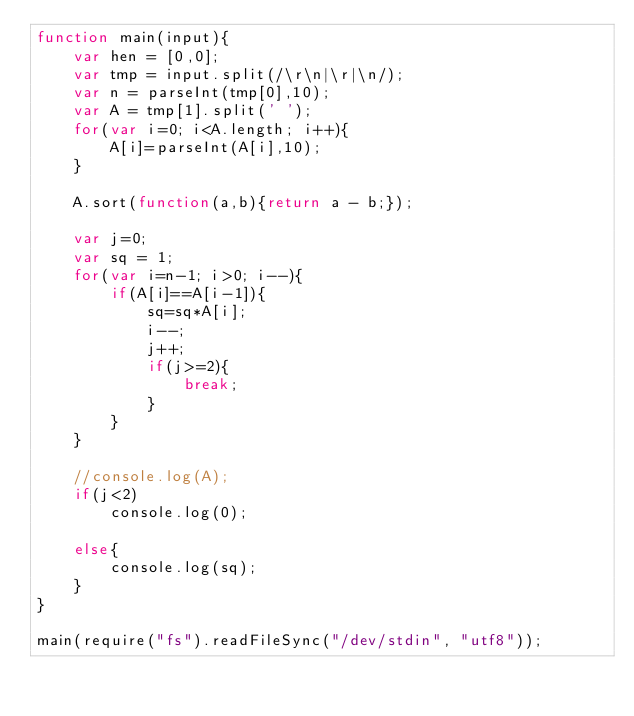Convert code to text. <code><loc_0><loc_0><loc_500><loc_500><_JavaScript_>function main(input){
    var hen = [0,0];
    var tmp = input.split(/\r\n|\r|\n/);
    var n = parseInt(tmp[0],10);
    var A = tmp[1].split(' ');
    for(var i=0; i<A.length; i++){
        A[i]=parseInt(A[i],10);
    }

    A.sort(function(a,b){return a - b;});

    var j=0;
    var sq = 1;
    for(var i=n-1; i>0; i--){
        if(A[i]==A[i-1]){
            sq=sq*A[i];
            i--;
            j++;
            if(j>=2){
                break;
            }
        }
    }

    //console.log(A);
    if(j<2)
        console.log(0);

    else{
        console.log(sq);
    }
}

main(require("fs").readFileSync("/dev/stdin", "utf8"));</code> 